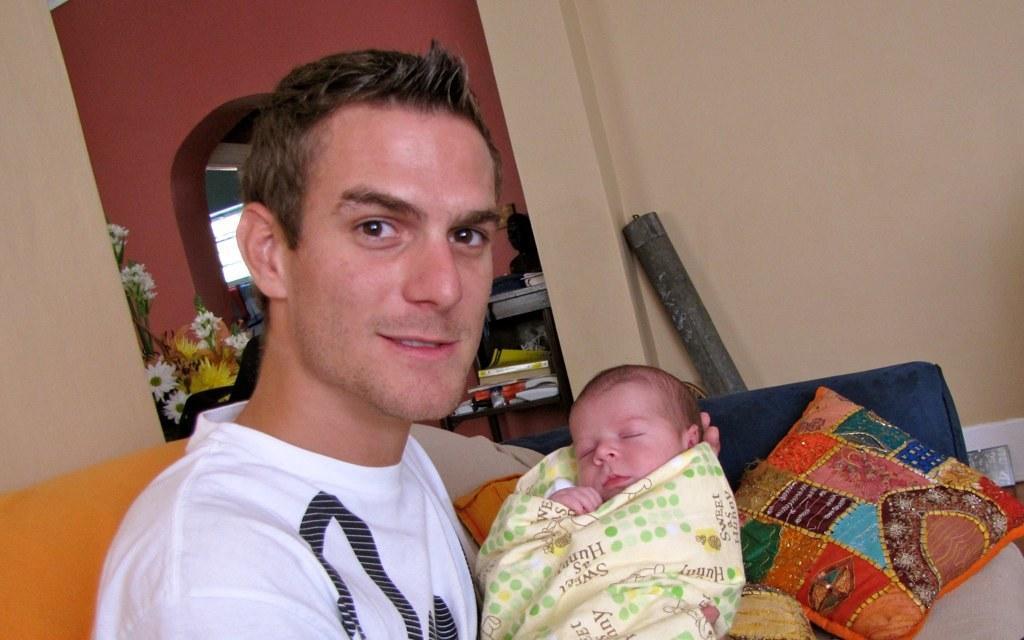Please provide a concise description of this image. This image consists of a man holding a kid. He is wearing a white T-shirt. On the right, we can see a pillow. In the background, there is a wall along with a mirror and flowers. Behind him, there is a rack in which there are books. 